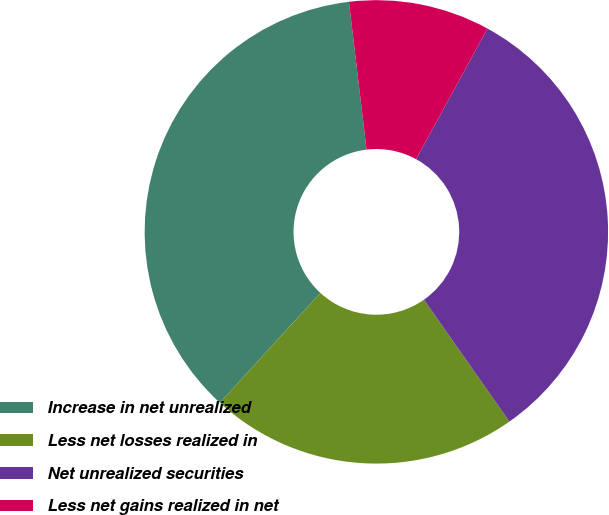Convert chart. <chart><loc_0><loc_0><loc_500><loc_500><pie_chart><fcel>Increase in net unrealized<fcel>Less net losses realized in<fcel>Net unrealized securities<fcel>Less net gains realized in net<nl><fcel>36.31%<fcel>21.54%<fcel>32.31%<fcel>9.85%<nl></chart> 